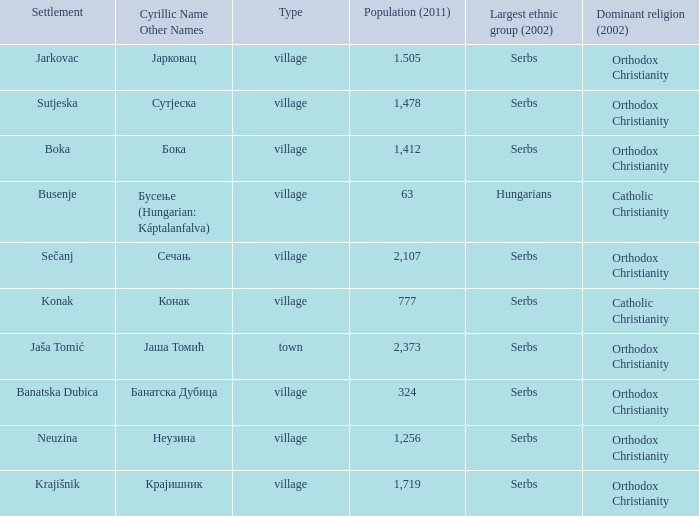What kind of type is  бока? Village. 